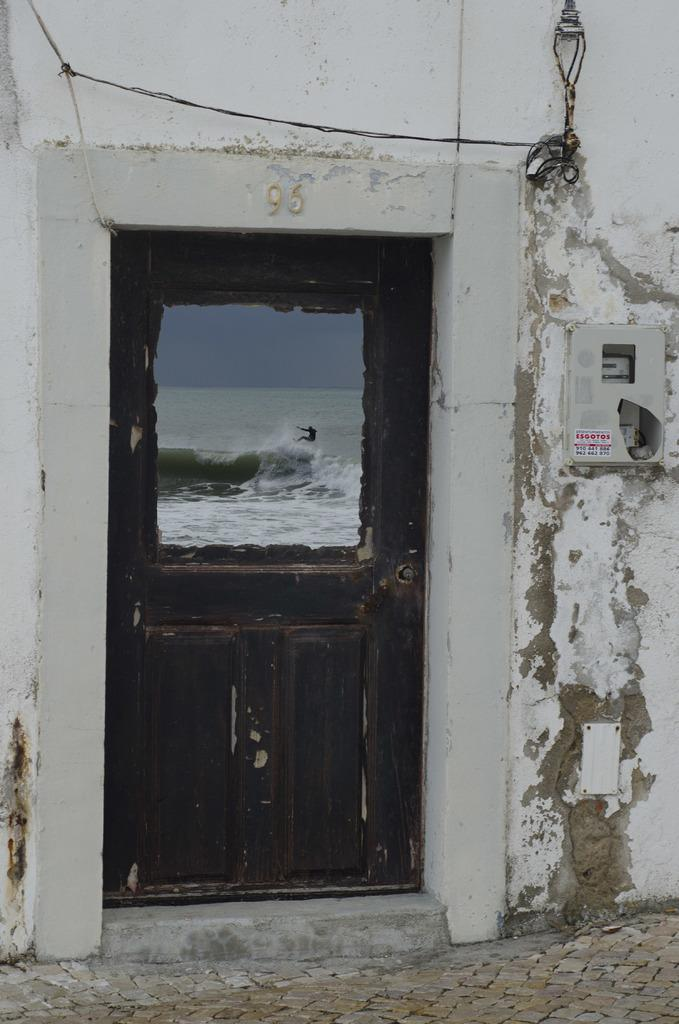What type of structure can be seen in the image? There is a door and a wall in the image. What object is present near the door? There is a box in the image. What type of path is visible in the image? There is a footpath in the image. What is the person doing in the image? A person is visible on water from the door. What type of fiction is the person reading while standing on water in the image? There is no indication that the person is reading any fiction in the image. What historical event is being depicted in the image? The image does not depict any specific historical event. 